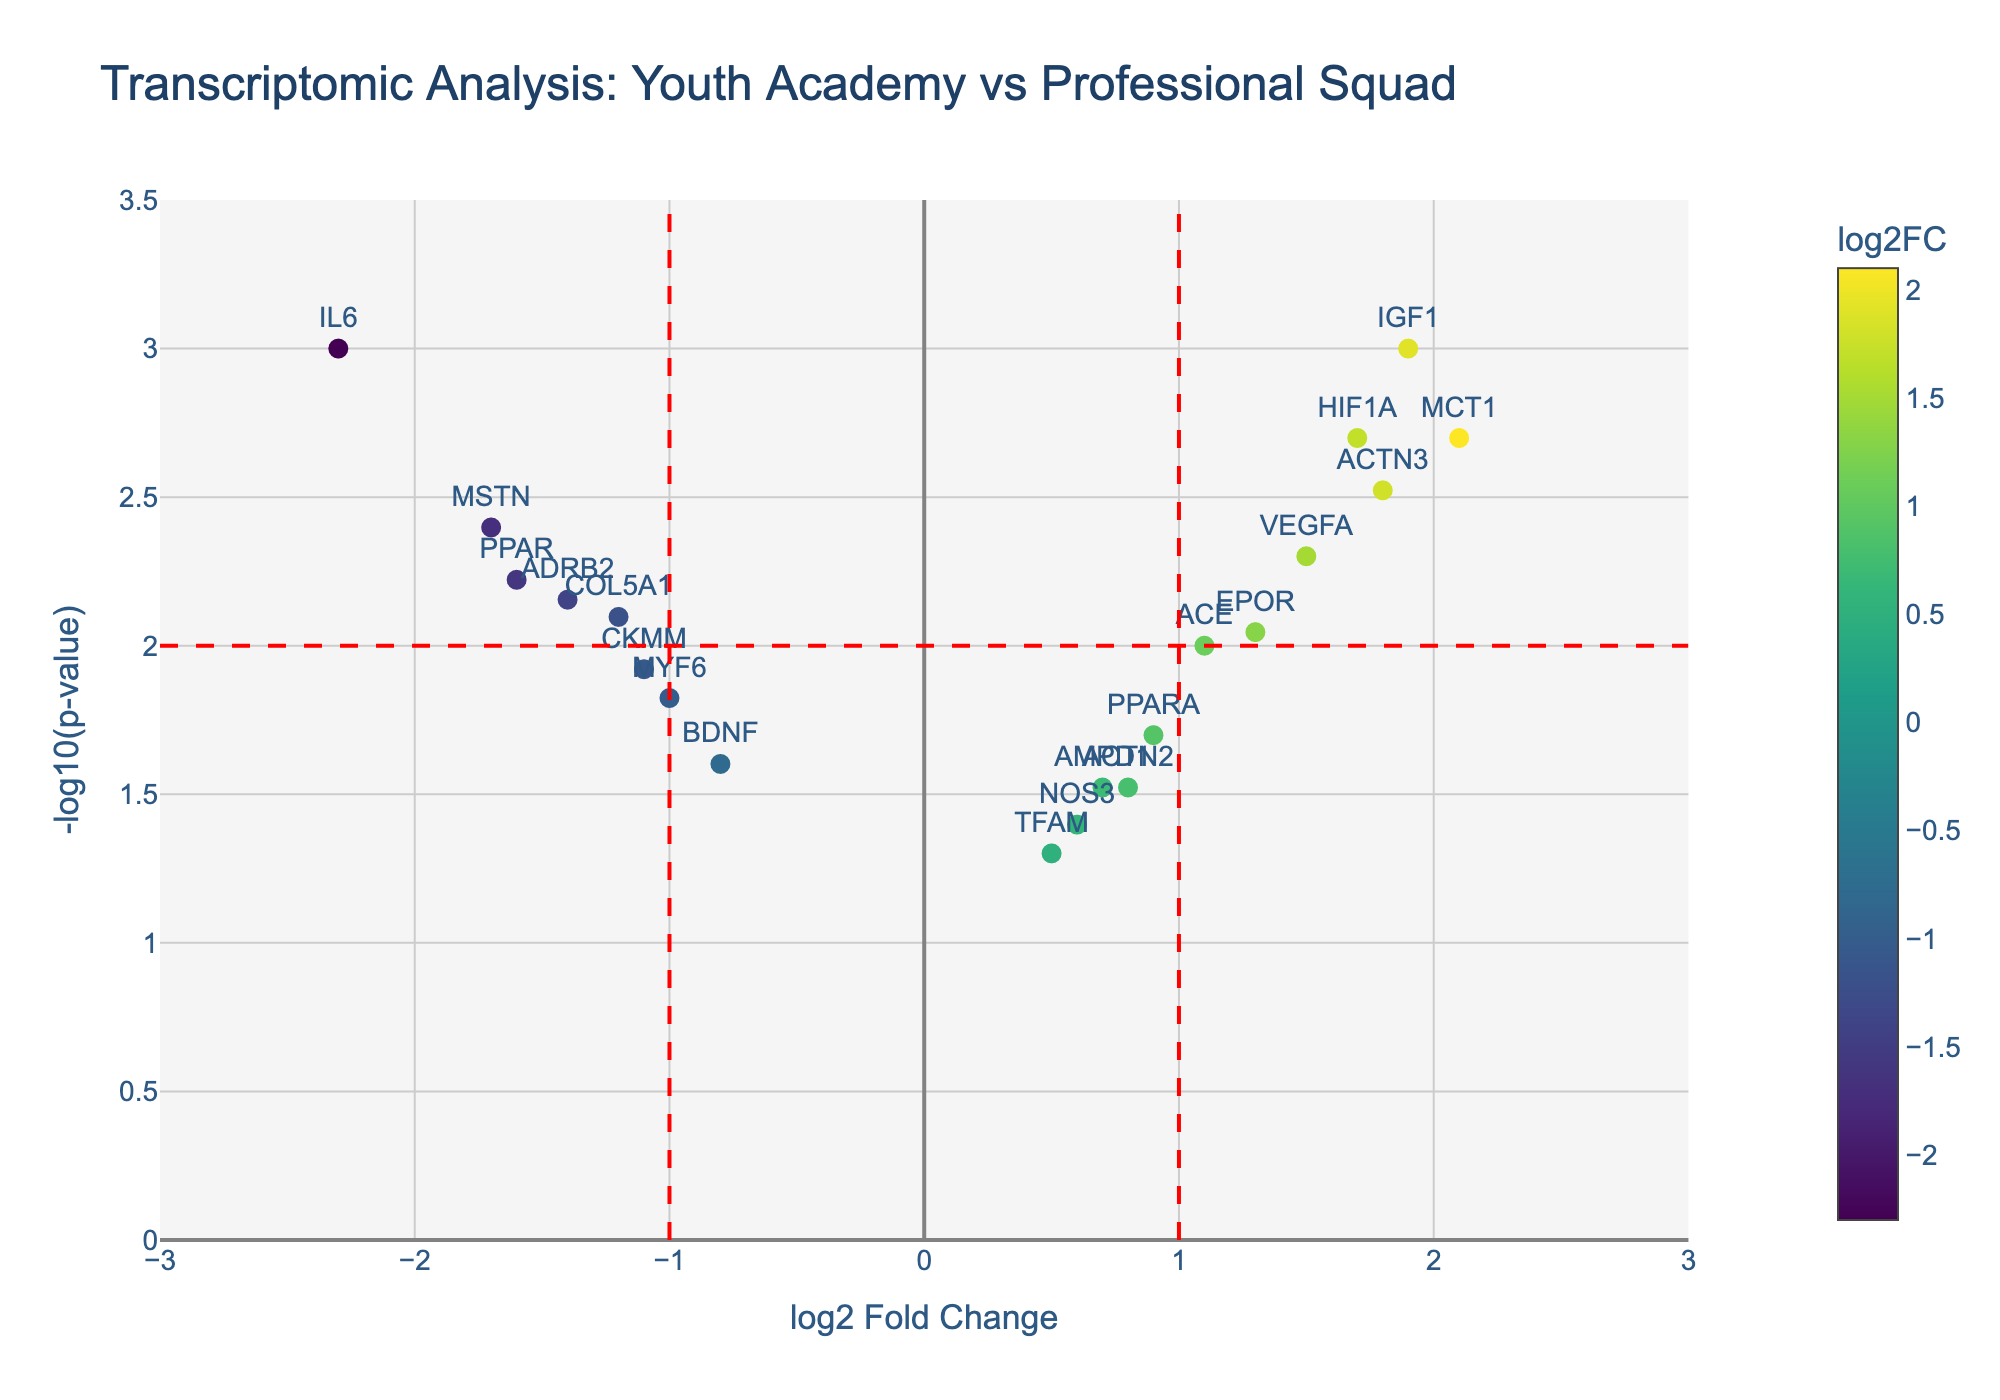How many genes have a log2 fold change greater than 1? Locate the vertical line at log2FC = 1 and count the number of points to the right side of this line. There are five genes (ACTN3, MCT1, IGF1, HIF1A, EPOR) that fall into this category.
Answer: 5 Which gene has the highest log2 fold change value? Identify the gene with the highest x-value on the scatter plot. MCT1 has the highest log2FC value among all genes displayed.
Answer: MCT1 Which gene has the most significant p-value? The most significant p-value corresponds to the highest y-value on the plot. Both IL6 and IGF1 have the highest -log10(p-value).
Answer: IL6 and IGF1 What is the log2 fold change and p-value for VEGFA? Find VEGFA on the plot and read its x and y values. The log2FC is 1.5 and the p-value is 0.005.
Answer: log2FC: 1.5, p-value: 0.005 How many genes are significantly downregulated? Significantly downregulated genes are located on the left to the vertical line at log2FC = -1 and above the horizontal line at -log10(p-value) = 2. There are three such genes: IL6, MSTN, and ADRB2.
Answer: 3 Which gene has the smallest log2 fold change among those with significant p-values? Exclude genes with -log10(p-value) < 2, then find the one with the smallest log2 fold change. BDNF, with a log2FC of -0.8, is the gene with the smallest log2FC among those with significant p-values.
Answer: BDNF How many genes have p-values greater than 0.05? Genes below the -log10(p-value) = -log10(0.05) = 1.3 line have p-values greater than 0.05. Only TFAM falls into this category.
Answer: 1 Which gene unsurprisingly has a log2 fold change closely around -1 and a p-value near 0.01? Look for genes around the intersection of log2FC = -1 and -log10(p-value) = 2. MYF6, with values of -1 and 0.015 respectively, fits well within this range.
Answer: MYF6 Is there any gene with a log2 fold change of exactly 0? Look along the y-axis at log2FC = 0; there are no data points exactly on this position in the plot.
Answer: No 